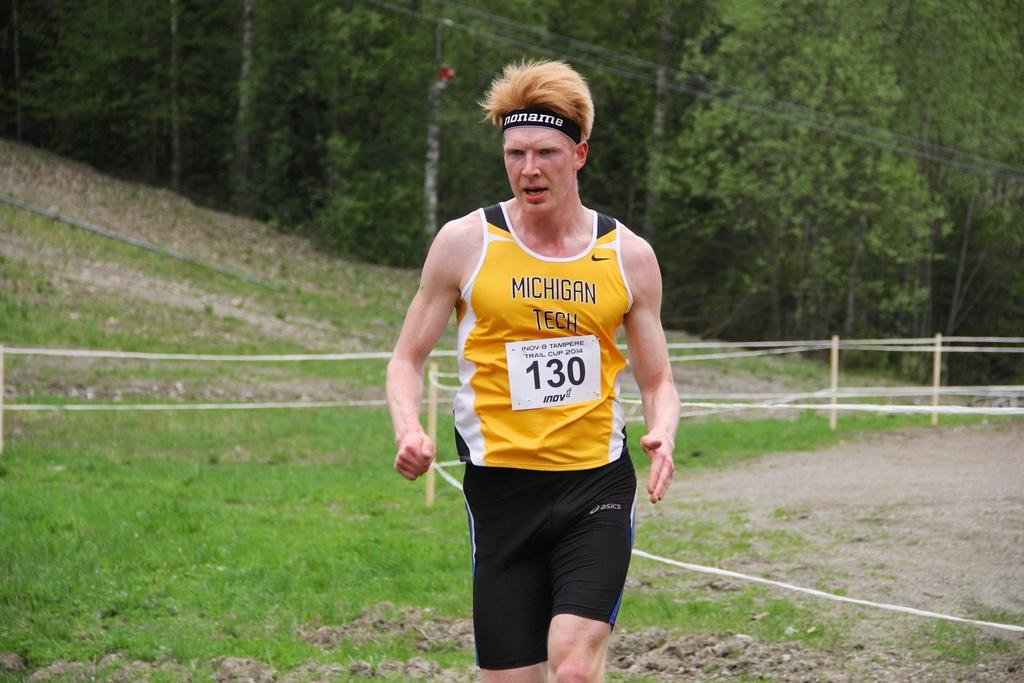<image>
Write a terse but informative summary of the picture. A runner with a yellow shirt from Michigan Tech. 